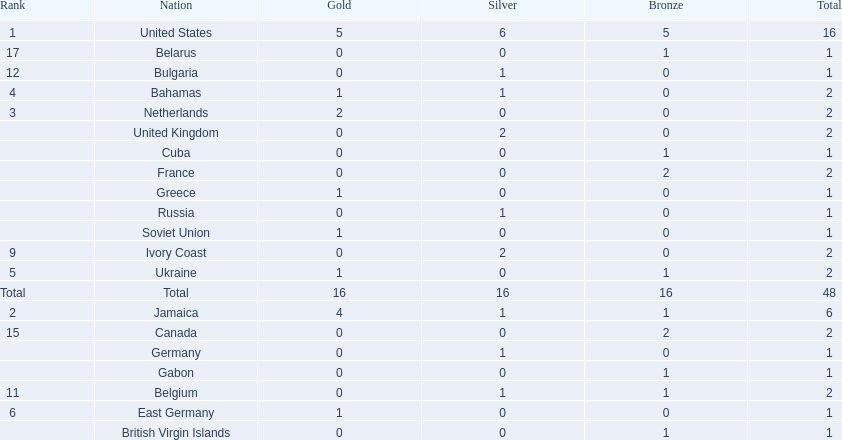What country won the most medals? United States. How many medals did the us win? 16. What is the most medals (after 16) that were won by a country? 6. Which country won 6 medals? Jamaica. 